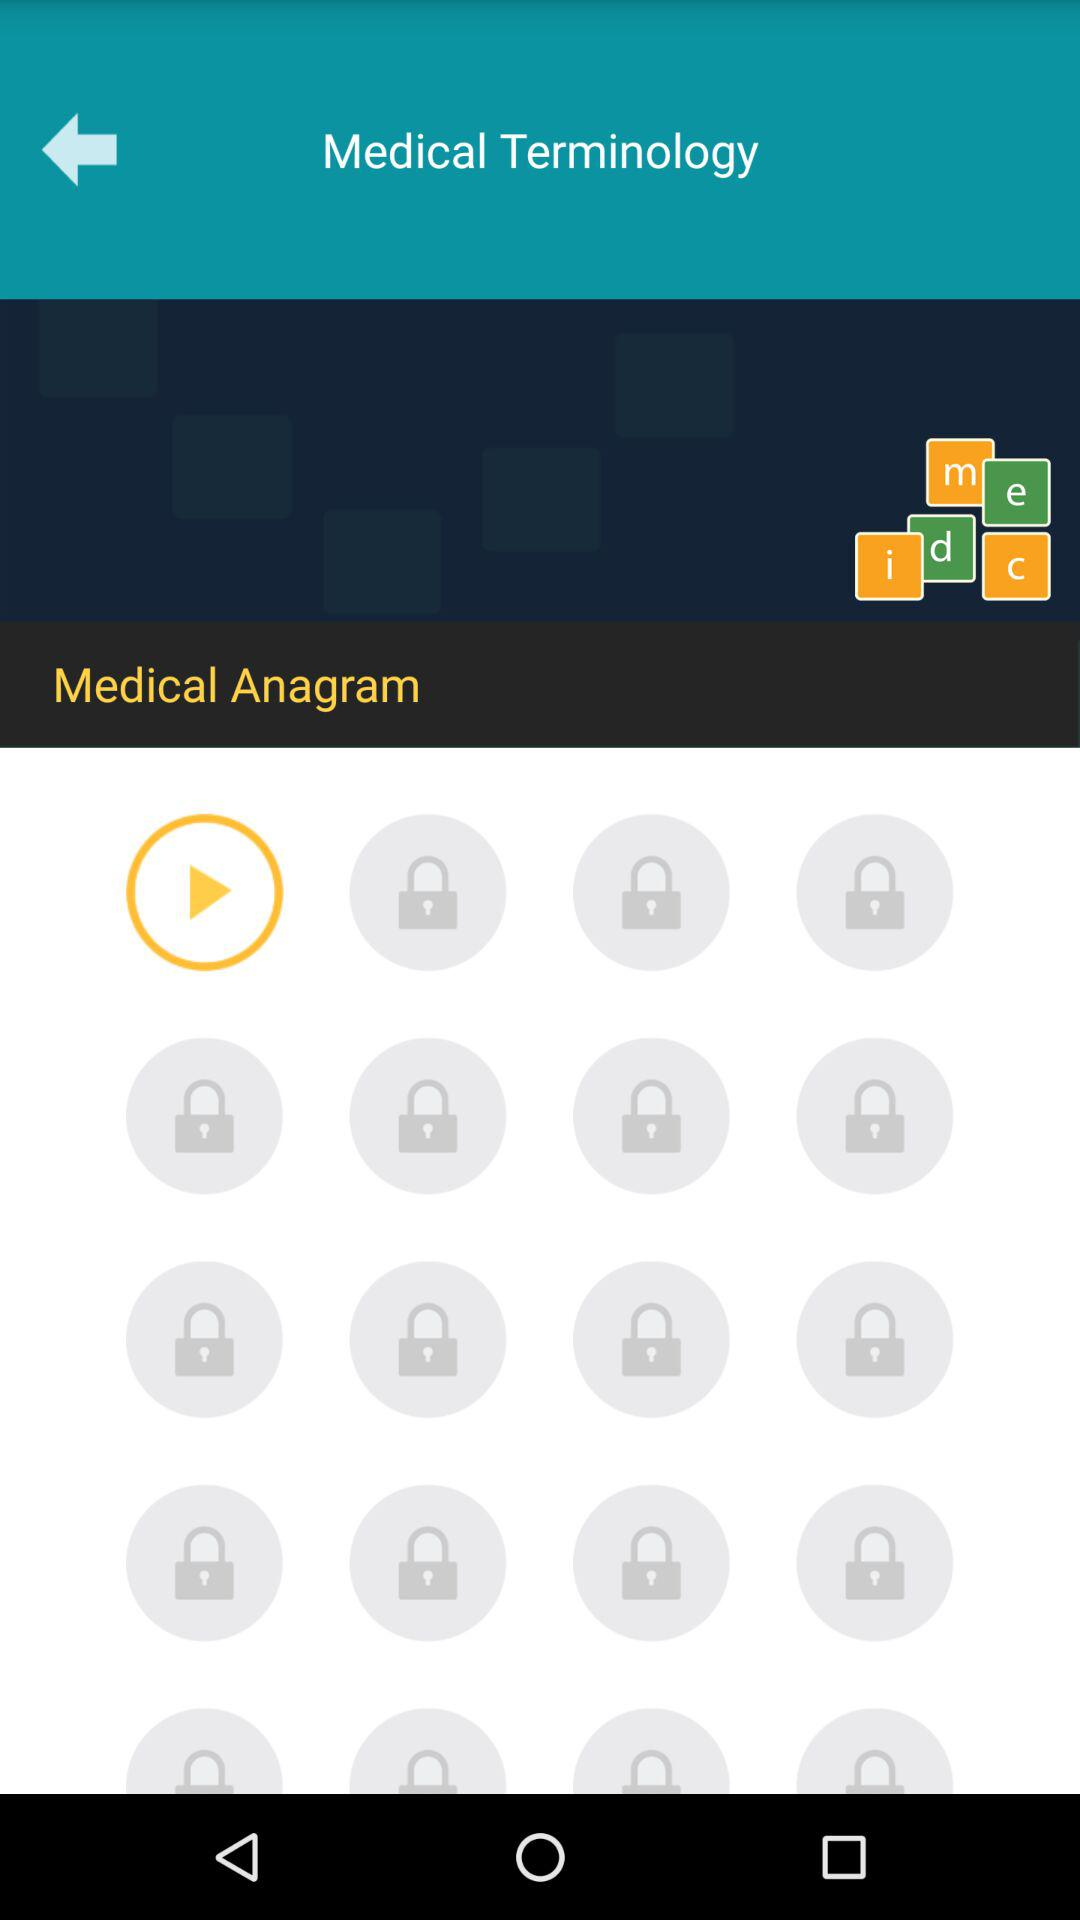Which medical term is given?
When the provided information is insufficient, respond with <no answer>. <no answer> 